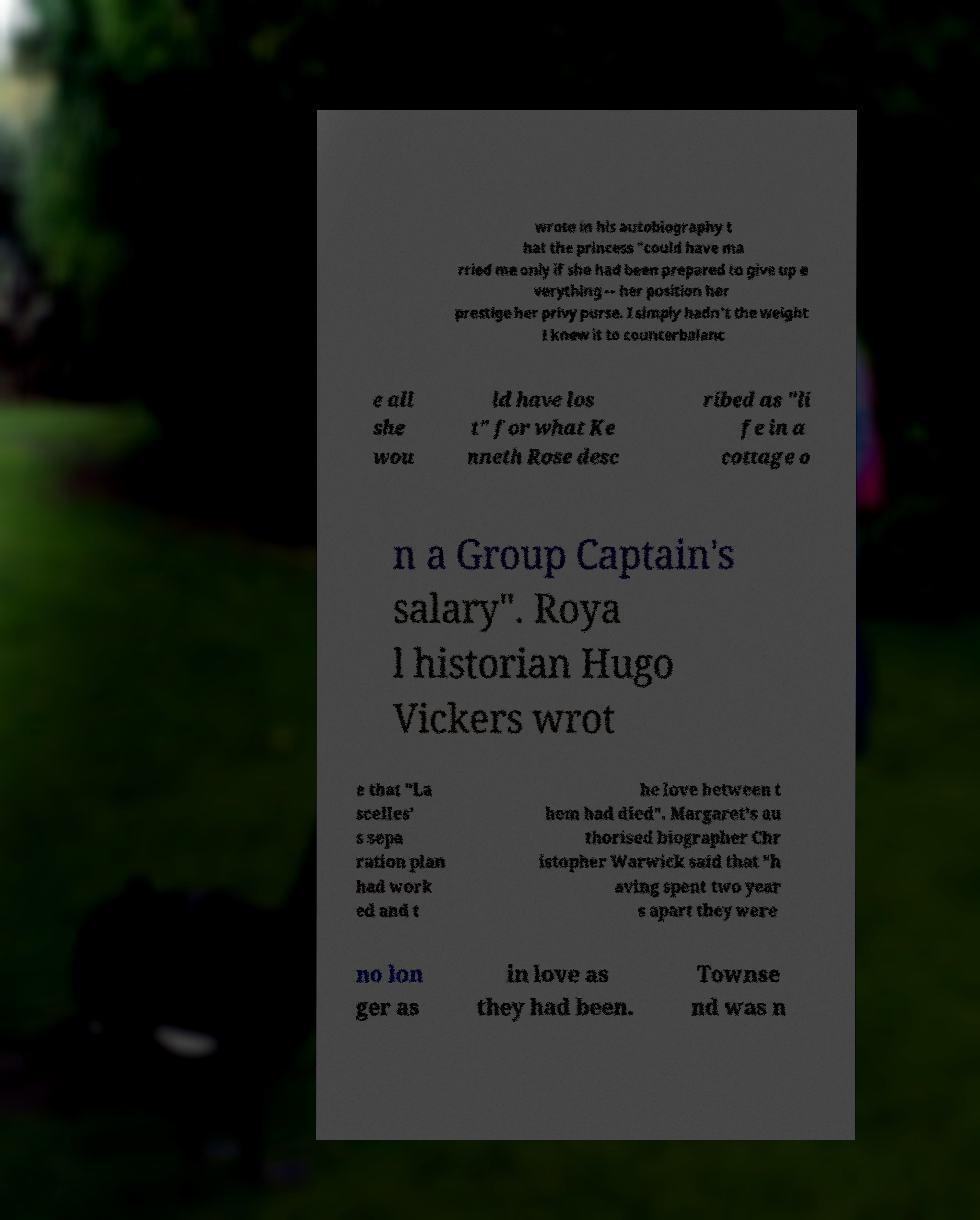Can you accurately transcribe the text from the provided image for me? wrote in his autobiography t hat the princess "could have ma rried me only if she had been prepared to give up e verything -- her position her prestige her privy purse. I simply hadn't the weight I knew it to counterbalanc e all she wou ld have los t" for what Ke nneth Rose desc ribed as "li fe in a cottage o n a Group Captain's salary". Roya l historian Hugo Vickers wrot e that "La scelles' s sepa ration plan had work ed and t he love between t hem had died". Margaret's au thorised biographer Chr istopher Warwick said that "h aving spent two year s apart they were no lon ger as in love as they had been. Townse nd was n 